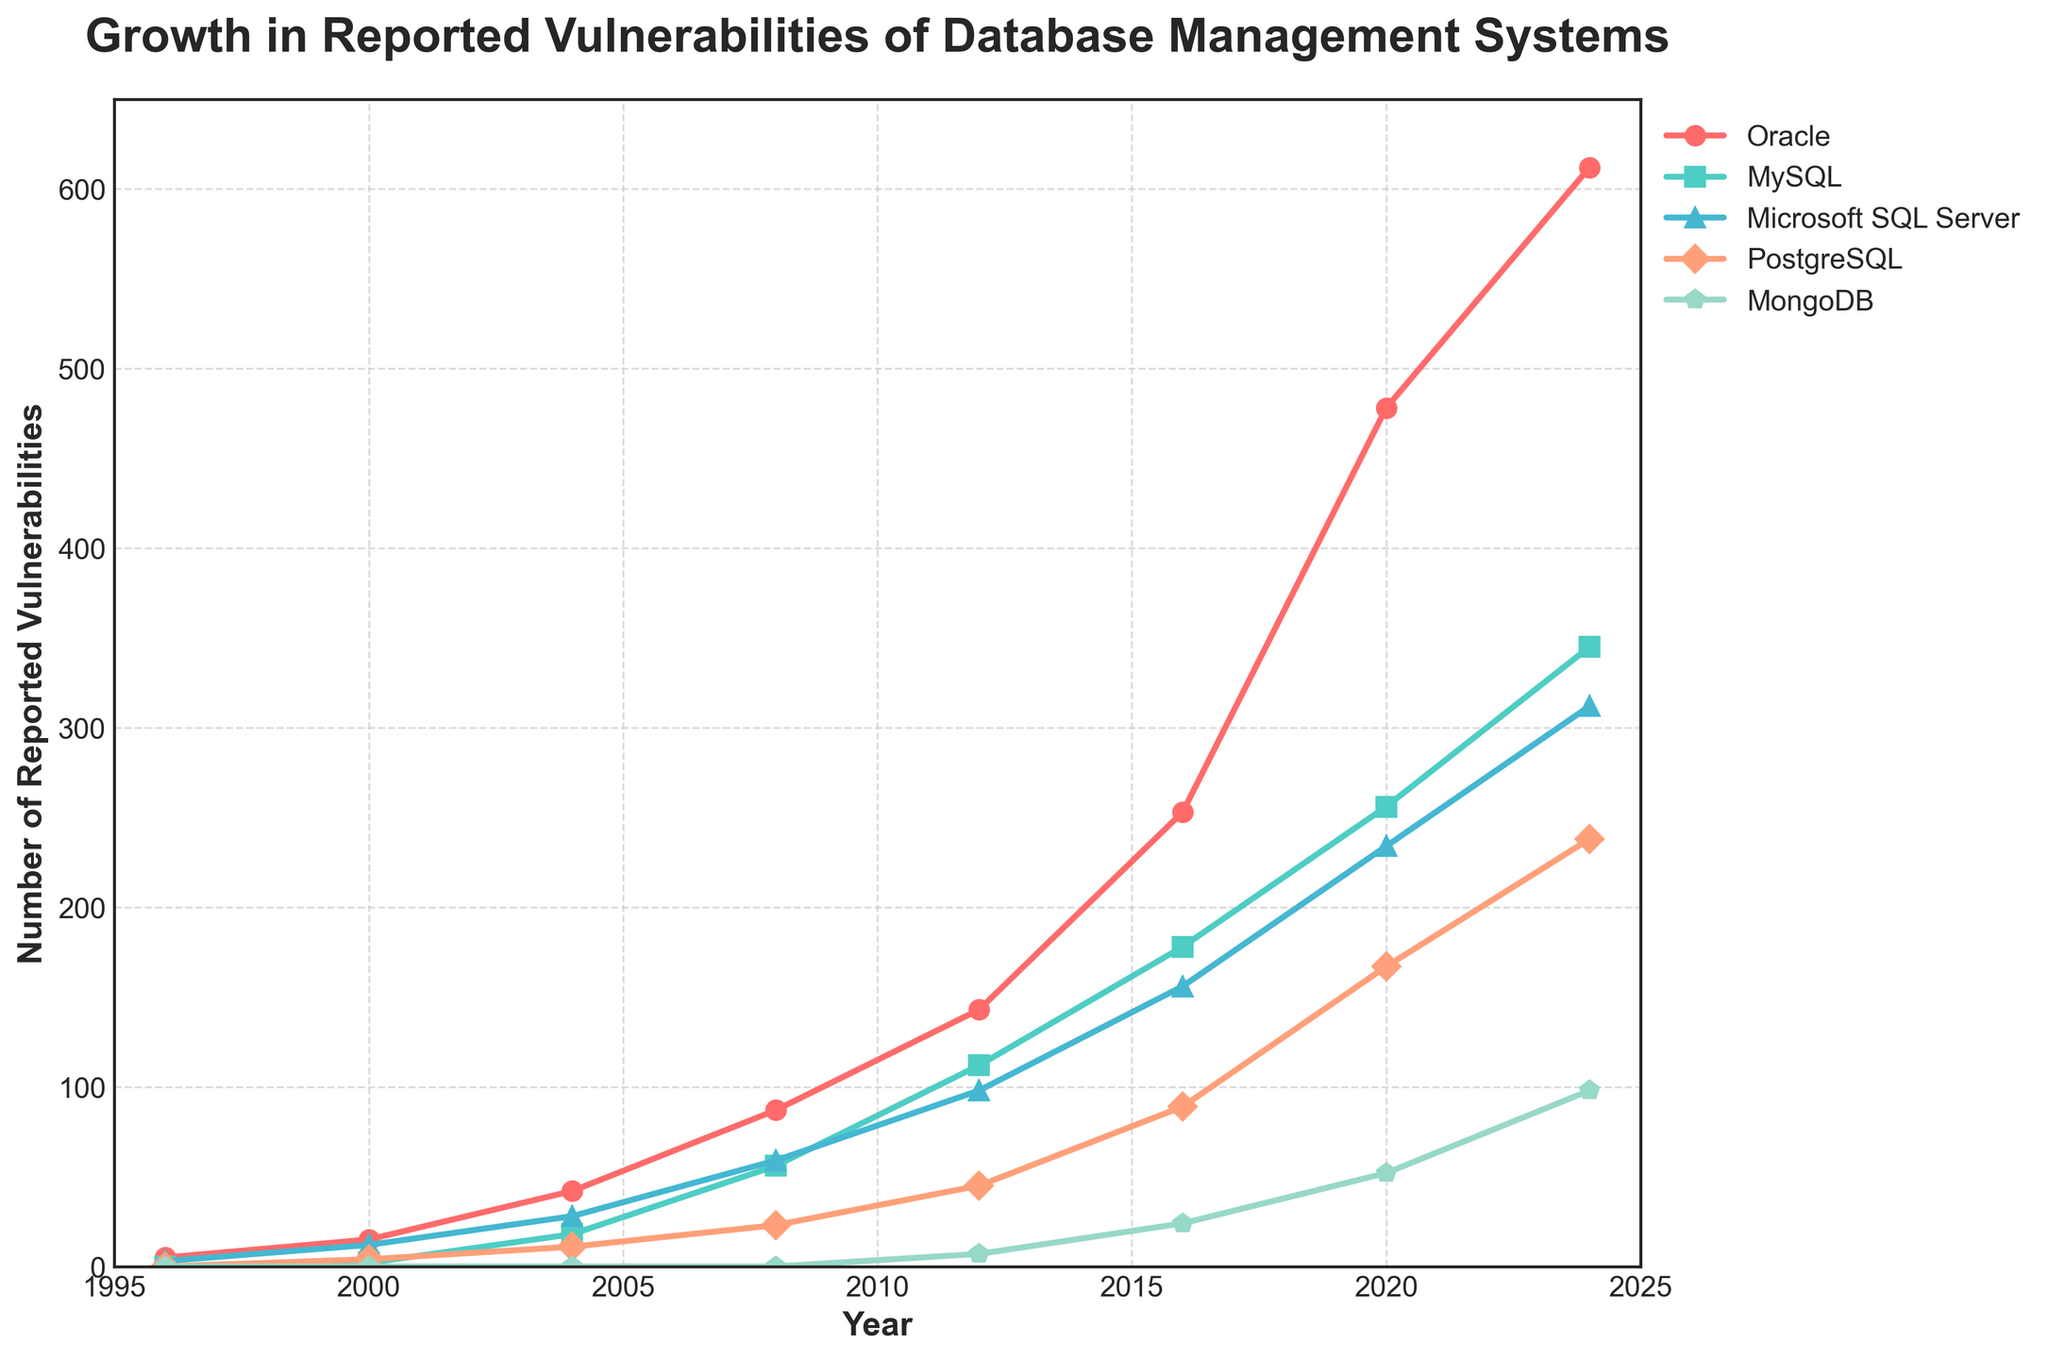Which year saw the highest number of reported vulnerabilities for Oracle? By looking at the line representing Oracle, it's the highest in 2024 with 612 vulnerabilities
Answer: 2024 How did the number of reported vulnerabilities for MongoDB change from 2016 to 2024? In 2016, MongoDB had 24 vulnerabilities and in 2024, it had 98. The change is 98 - 24 = 74
Answer: 74 Which database management system had the lowest number of vulnerabilities reported in 2008? By comparing all the values for 2008, MongoDB had the lowest with 0 vulnerabilities
Answer: MongoDB In which year did MySQL surpass 200 reported vulnerabilities? The line for MySQL passes the 200 mark between 2016 and 2020. In 2020, MySQL had 256 vulnerabilities, so it surpassed 200 in 2020
Answer: 2020 On average, how many vulnerabilities did PostgreSQL have from 2000 to 2024? Add the reported vulnerabilities for PostgreSQL from 2000 to 2024 (4 + 11 + 23 + 45 + 89 + 167 + 238) = 577 and divide by 7 years, 577/7 = 82.43
Answer: 82.43 Between 2012 and 2016, which database management system showed the largest increase in the number of reported vulnerabilities? Calculate the increase for each database management system: Oracle: 253 - 143 = 110, MySQL: 178 - 112 = 66, Microsoft SQL Server: 156 - 98 = 58, PostgreSQL: 89 - 45 = 44, MongoDB: 24 - 7 = 17. The largest increase is for Oracle with an increase of 110 vulnerabilities
Answer: Oracle Compare the number of reported vulnerabilities for Microsoft SQL Server in 2004 and PostgreSQL in 2020. Which one is higher? Microsoft SQL Server had 28 vulnerabilities in 2004, and PostgreSQL had 167 in 2020. PostgreSQL in 2020 is higher
Answer: PostgreSQL in 2020 What is the difference in the number of reported vulnerabilities between MySQL and MongoDB in 2024? MySQL had 345 vulnerabilities, and MongoDB had 98 in 2024. The difference is 345 - 98 = 247
Answer: 247 Which database management system had a steady increase in vulnerabilities every reporting year shown in the plot? Evaluate each line: Oracle, MySQL, Microsoft SQL Server, and PostgreSQL all generally show a steady increase. MongoDB stays at zero until 2012 and then steadily increases from 7 to 98
Answer: Oracle, MySQL, Microsoft SQL Server, PostgreSQL 